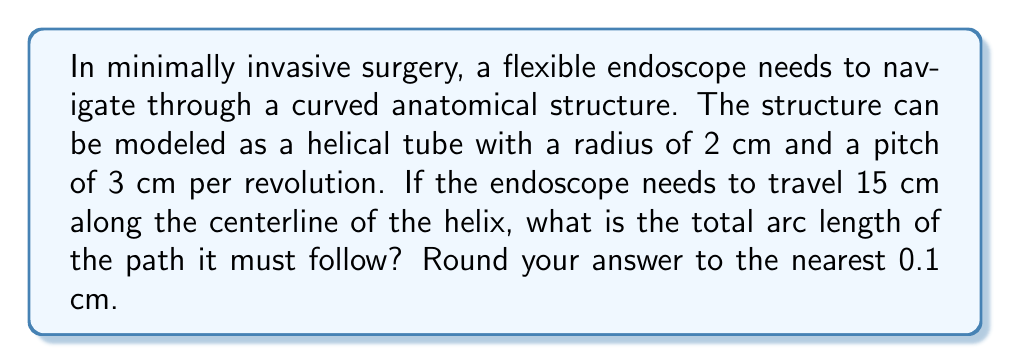Teach me how to tackle this problem. To solve this problem, we'll use concepts from differential geometry, specifically the arc length formula for a helix. Let's approach this step-by-step:

1) The parametric equations for a helix are:
   $$x = r \cos(t)$$
   $$y = r \sin(t)$$
   $$z = ct$$
   where $r$ is the radius and $c$ is related to the pitch.

2) Given:
   - Radius $r = 2$ cm
   - Pitch = 3 cm per revolution
   - Distance along centerline = 15 cm

3) First, we need to find $c$. Since the pitch is 3 cm per revolution:
   $$c = \frac{3}{2\pi} \approx 0.477$$

4) The arc length of a helix is given by:
   $$s = \int_0^T \sqrt{r^2(\frac{dx}{dt})^2 + r^2(\frac{dy}{dt})^2 + (\frac{dz}{dt})^2} dt$$
   $$= \int_0^T \sqrt{r^2(-\sin(t))^2 + r^2(\cos(t))^2 + c^2} dt$$
   $$= \int_0^T \sqrt{r^2 + c^2} dt$$
   $$= T\sqrt{r^2 + c^2}$$

5) We need to find $T$. Since the endoscope travels 15 cm along the centerline:
   $$15 = cT$$
   $$T = \frac{15}{c} \approx 31.45$$

6) Now we can calculate the arc length:
   $$s = T\sqrt{r^2 + c^2}$$
   $$\approx 31.45 \sqrt{2^2 + 0.477^2}$$
   $$\approx 31.45 \sqrt{4.228}$$
   $$\approx 31.45 * 2.056$$
   $$\approx 64.66 \text{ cm}$$

7) Rounding to the nearest 0.1 cm:
   $$s \approx 64.7 \text{ cm}$$
Answer: 64.7 cm 